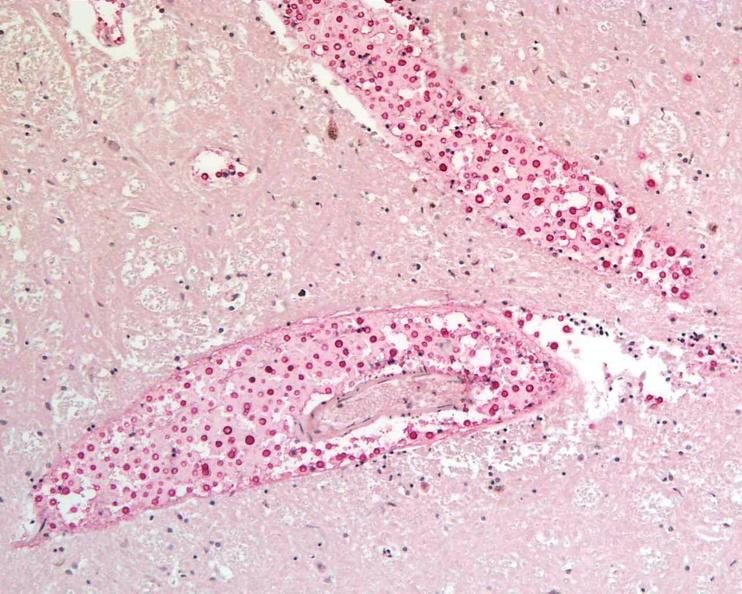what does this image show?
Answer the question using a single word or phrase. Brain 